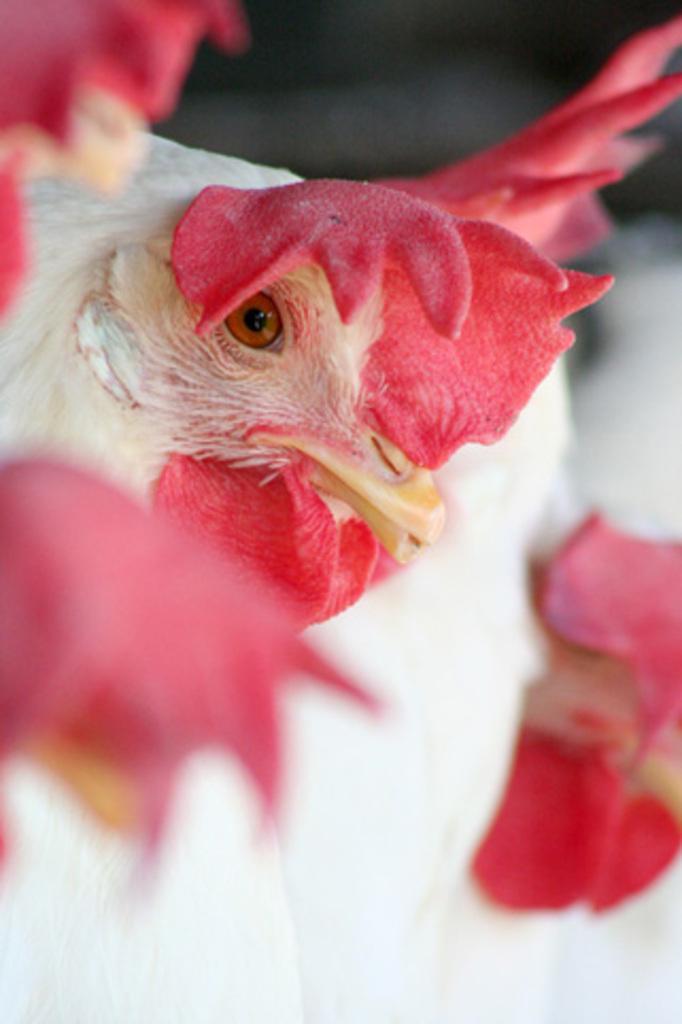Please provide a concise description of this image. This image consists of birds. 